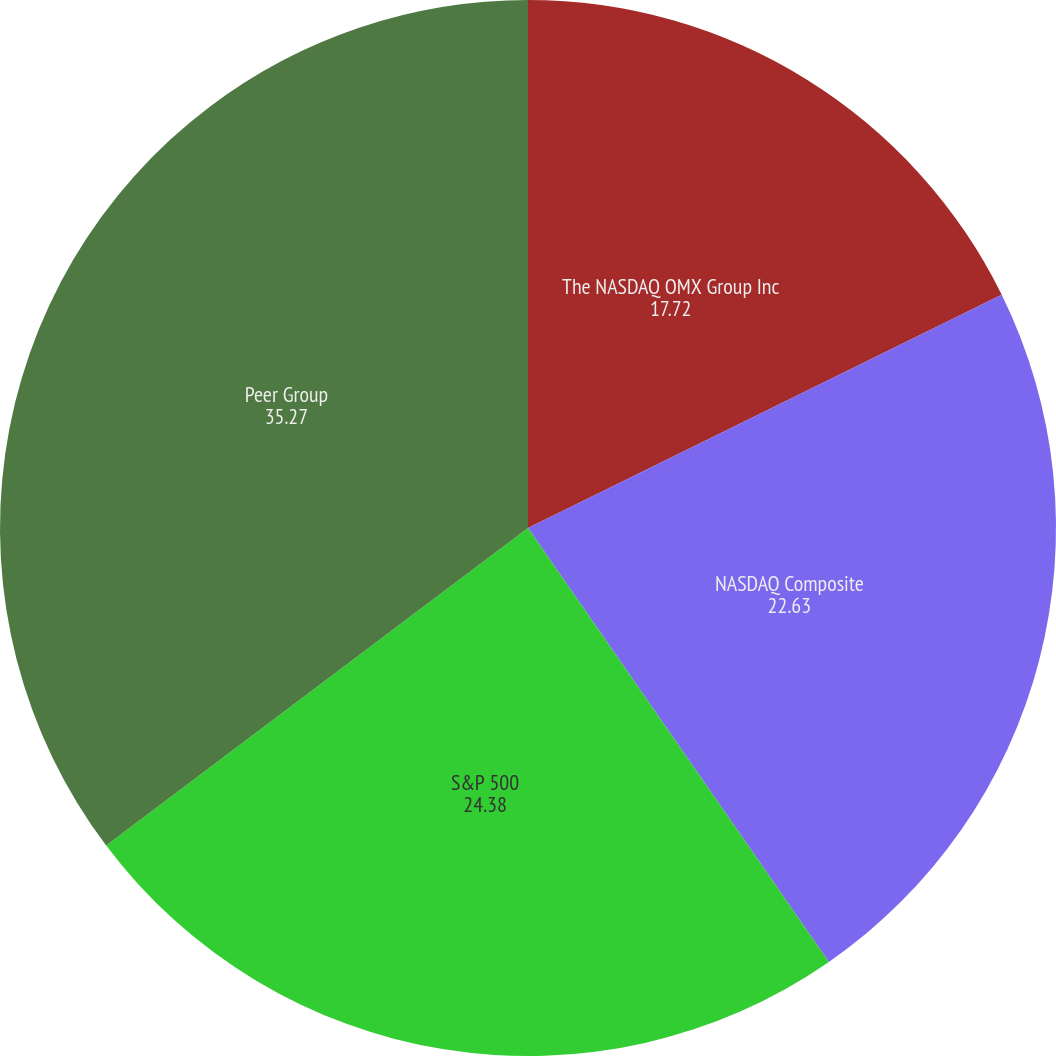Convert chart to OTSL. <chart><loc_0><loc_0><loc_500><loc_500><pie_chart><fcel>The NASDAQ OMX Group Inc<fcel>NASDAQ Composite<fcel>S&P 500<fcel>Peer Group<nl><fcel>17.72%<fcel>22.63%<fcel>24.38%<fcel>35.27%<nl></chart> 